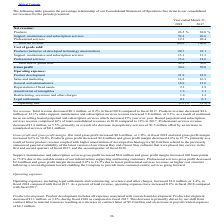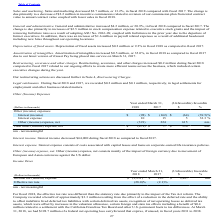According to Agilysys's financial document, What was the decrease in total revenue? $0.3 million, or 0.2%. The document states: "Net revenue. Total revenue decreased $0.3 million, or 0.2% in fiscal 2018 compared to fiscal 2017. Products revenue decreased $4.6 million or 12.1% wh..." Also, What was the decrease in Professional services revenue? $1.4 million, or 5.5%. The document states: "% in 2017. Professional services revenue decreased $1.4 million, or 5.5%, primarily as a result of a decrease in proprietary services of $1.5 million ..." Also, What was the increase in gross profit margin? $0.6 million, or 1.0%. The document states: "ss profit margin. Our total gross profit increased $0.6 million, or 1.0%, in fiscal 2018 and total gross profit margin increased 0.6% to 50.6%. Produc..." Also, can you calculate: What was the increase / (decrease) in the percentage of Professional services of net revenue from 2017 to 2018? Based on the calculation: 19.3 - 20.4, the result is -1.1 (percentage). This is based on the information: "Professional services 19.3 20.4 Professional services 19.3 20.4..." The key data points involved are: 19.3, 20.4. Also, can you calculate: What was total gross profit in 2017? To answer this question, I need to perform calculations using the financial data. The calculation is: 0.6/1.0*100, which equals 60 (in millions). This is based on the information: "Our total gross profit increased $0.6 million, or 1.0%, in fiscal 2018 and total gross profit margin increased 0.6% to 50.6%. Products gross profit decre Gross profit 50.6 50.0 Gross profit 50.6 50.0..." The key data points involved are: 0.6, 1.0. Also, can you calculate: What was total gross profit in 2018? To answer this question, I need to perform calculations using the financial data. The calculation is: 0.6/1.0*100+0.6, which equals 60.6 (in millions). This is based on the information: "Our total gross profit increased $0.6 million, or 1.0%, in fiscal 2018 and total gross profit margin increased 0.6% to 50.6%. Products gross profit decre Gross profit 50.6 50.0 Gross profit 50.6 50.0..." The key data points involved are: 1.0. 